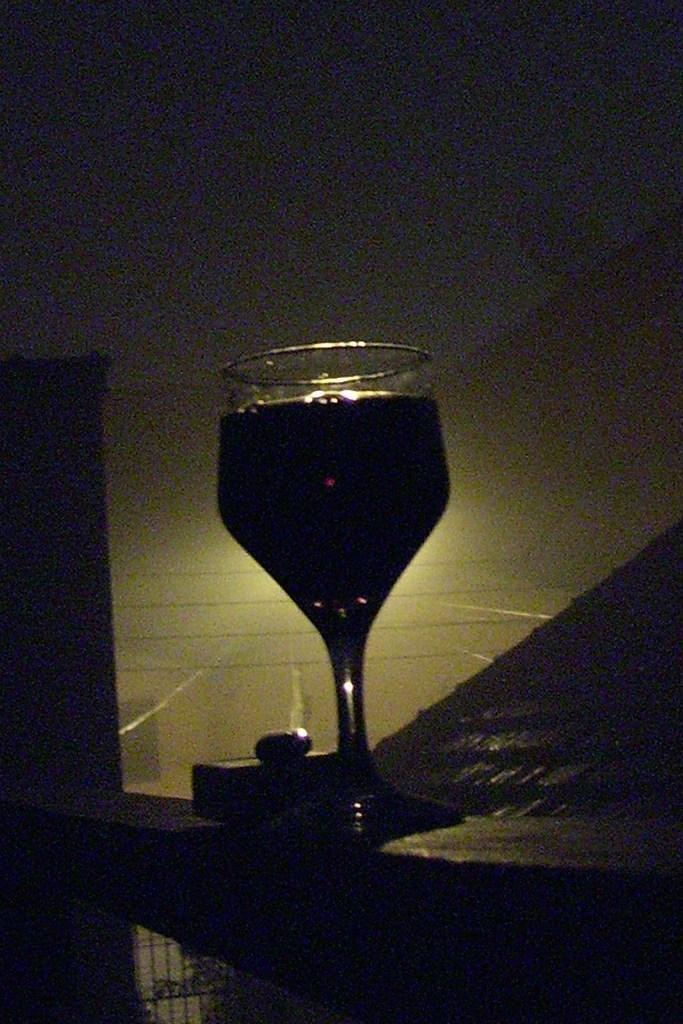Could you give a brief overview of what you see in this image? This is a zoomed in picture. In the center there is a glass of drink placed on an object. In the background there is a wall and some other objects. 